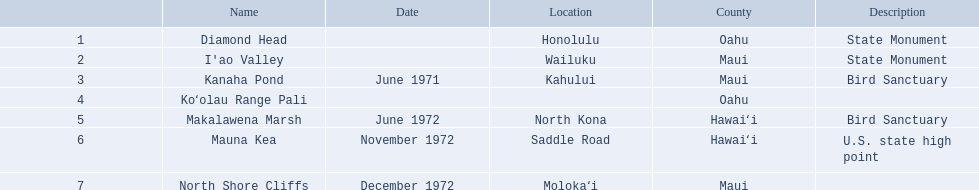What are all the names of the landmarks? Diamond Head, I'ao Valley, Kanaha Pond, Koʻolau Range Pali, Makalawena Marsh, Mauna Kea, North Shore Cliffs. Where can they be found? Honolulu, Wailuku, Kahului, , North Kona, Saddle Road, Molokaʻi. And which landmark has no specified location? Koʻolau Range Pali. Can you give me this table as a dict? {'header': ['', 'Name', 'Date', 'Location', 'County', 'Description'], 'rows': [['1', 'Diamond Head', '', 'Honolulu', 'Oahu', 'State Monument'], ['2', "I'ao Valley", '', 'Wailuku', 'Maui', 'State Monument'], ['3', 'Kanaha Pond', 'June 1971', 'Kahului', 'Maui', 'Bird Sanctuary'], ['4', 'Koʻolau Range Pali', '', '', 'Oahu', ''], ['5', 'Makalawena Marsh', 'June 1972', 'North Kona', 'Hawaiʻi', 'Bird Sanctuary'], ['6', 'Mauna Kea', 'November 1972', 'Saddle Road', 'Hawaiʻi', 'U.S. state high point'], ['7', 'North Shore Cliffs', 'December 1972', 'Molokaʻi', 'Maui', '']]} What are the diverse titles for landmarks? Diamond Head, I'ao Valley, Kanaha Pond, Koʻolau Range Pali, Makalawena Marsh, Mauna Kea, North Shore Cliffs. Which among them is placed in hawai'i county? Makalawena Marsh, Mauna Kea. Which one does not refer to mauna kea? Makalawena Marsh. 